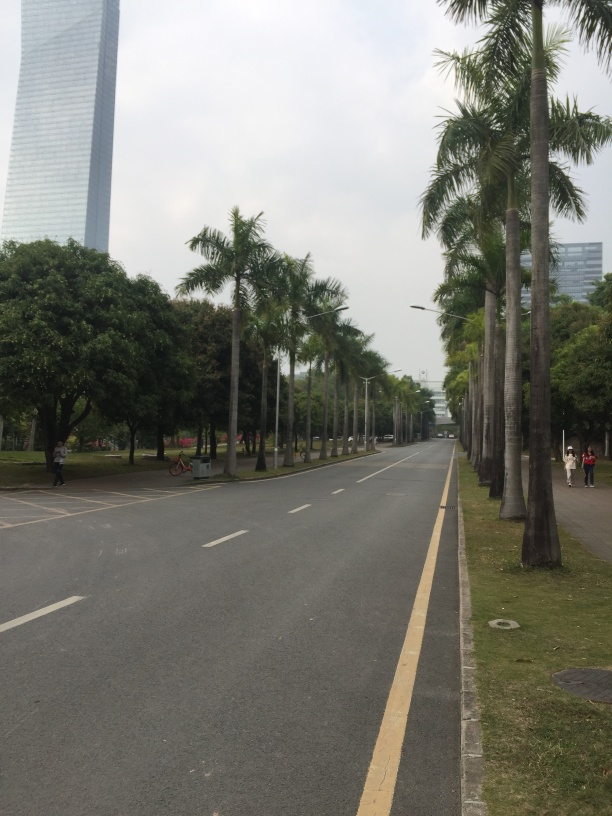How would you rate the overall quality of this image? Considering the clarity, composition, and exposure, the image quality is good. It's well-lit, with clear details and balanced composition. The wide street lined with palm trees, the calmness of the environment, and the modern building in the background collectively give the photo a serene and organized look. However, there could be room for improvement in terms of excitement or focal points that could make the image more engaging. 